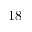<formula> <loc_0><loc_0><loc_500><loc_500>1 8</formula> 